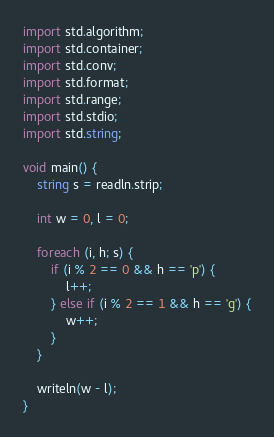Convert code to text. <code><loc_0><loc_0><loc_500><loc_500><_D_>import std.algorithm;
import std.container;
import std.conv;
import std.format;
import std.range;
import std.stdio;
import std.string;

void main() {
    string s = readln.strip;

    int w = 0, l = 0;

    foreach (i, h; s) {
        if (i % 2 == 0 && h == 'p') {
            l++;
        } else if (i % 2 == 1 && h == 'g') {
            w++;
        }
    }

    writeln(w - l);
}
</code> 